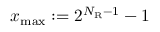<formula> <loc_0><loc_0><loc_500><loc_500>x _ { \max } \colon = 2 ^ { N _ { R } - 1 } - 1</formula> 